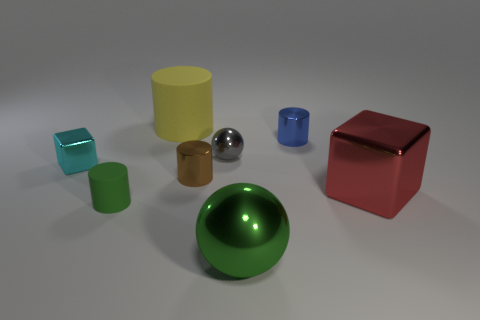Add 2 big spheres. How many objects exist? 10 Subtract all blocks. How many objects are left? 6 Subtract all big red metallic blocks. Subtract all metal objects. How many objects are left? 1 Add 4 big red objects. How many big red objects are left? 5 Add 2 small blue spheres. How many small blue spheres exist? 2 Subtract 1 green spheres. How many objects are left? 7 